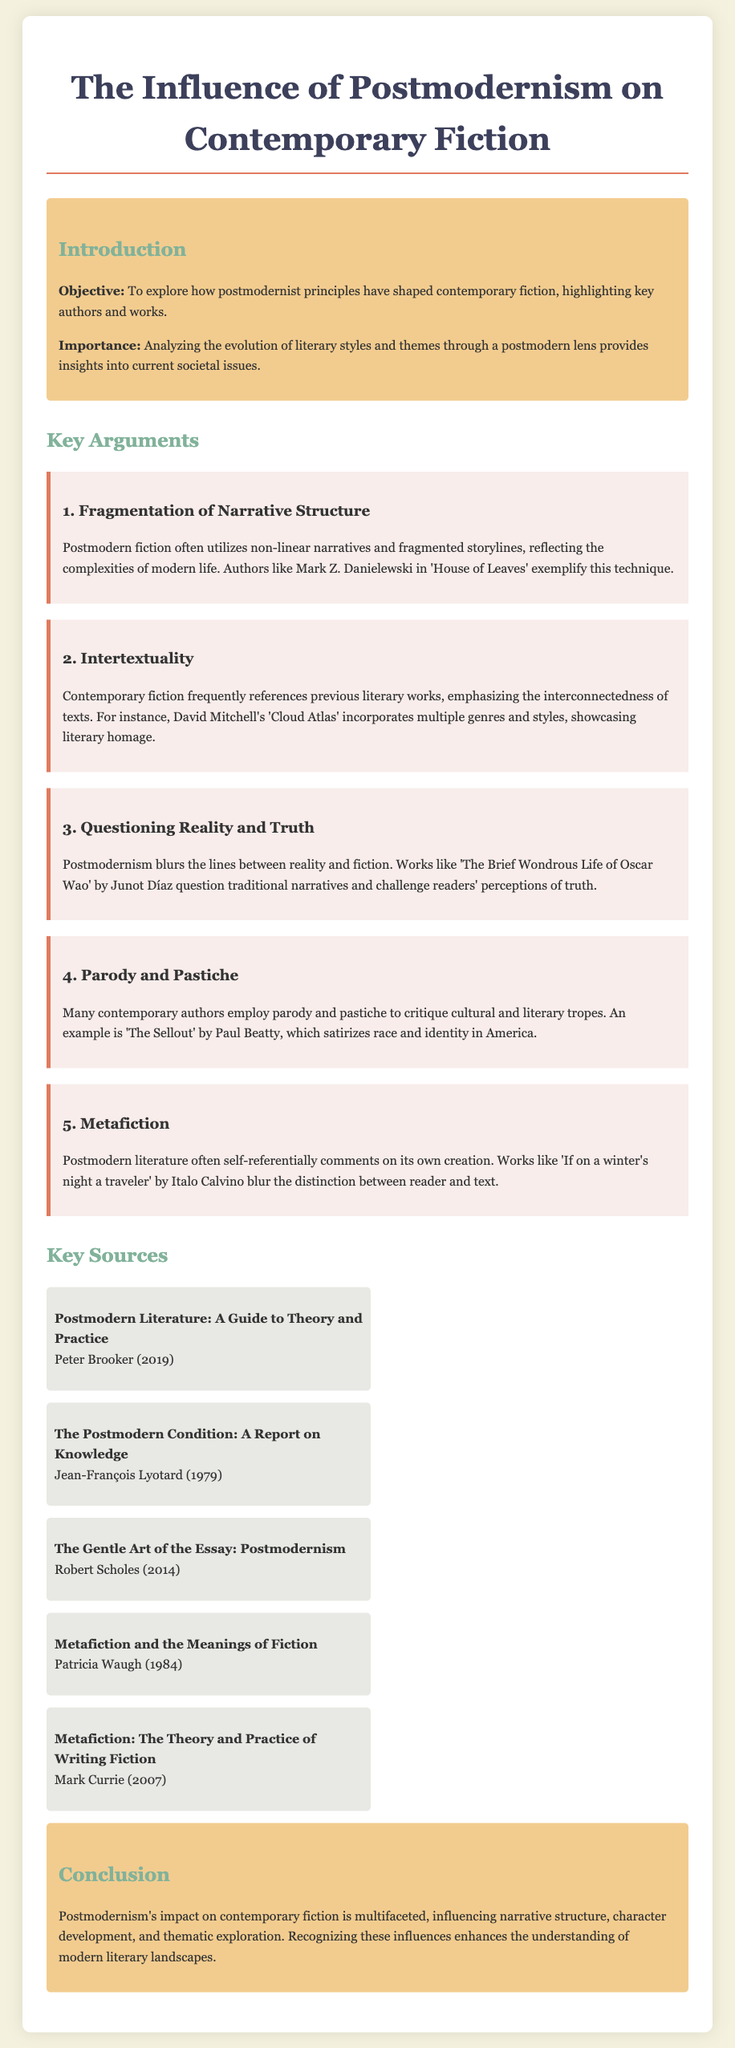What is the title of the thesis paper? The title is mentioned prominently at the top of the document as the main heading.
Answer: The Influence of Postmodernism on Contemporary Fiction What is the first key argument presented? The first key argument is listed under the Key Arguments section, detailing its focus and example.
Answer: Fragmentation of Narrative Structure Who is the author of 'House of Leaves'? The author of 'House of Leaves' is provided in the context of the example for the first argument.
Answer: Mark Z. Danielewski Which year was "The Postmodern Condition: A Report on Knowledge" published? The publication year is provided next to the title in the Key Sources section.
Answer: 1979 What literary technique is discussed in relation to David Mitchell's works? The technique is specifically highlighted while explaining the concept of intertextuality within contemporary fiction.
Answer: Intertextuality What overarching theme does the conclusion emphasize? The conclusion summarizes the influence of a specific literary movement on fiction, revealing its broader implications.
Answer: Multifaceted influence Which author is associated with the work "The Sellout"? The document states the author's name in relation to the discussion of parody and pastiche.
Answer: Paul Beatty How many key sources are listed in the document? The number of sources can be counted in the Key Sources section of the document.
Answer: Five 